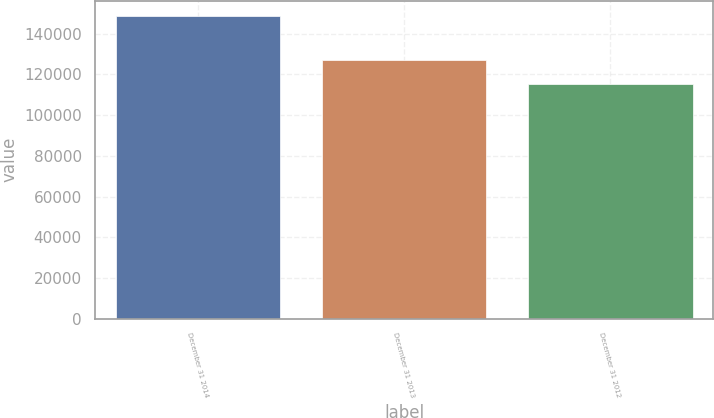<chart> <loc_0><loc_0><loc_500><loc_500><bar_chart><fcel>December 31 2014<fcel>December 31 2013<fcel>December 31 2012<nl><fcel>148696<fcel>127225<fcel>115199<nl></chart> 